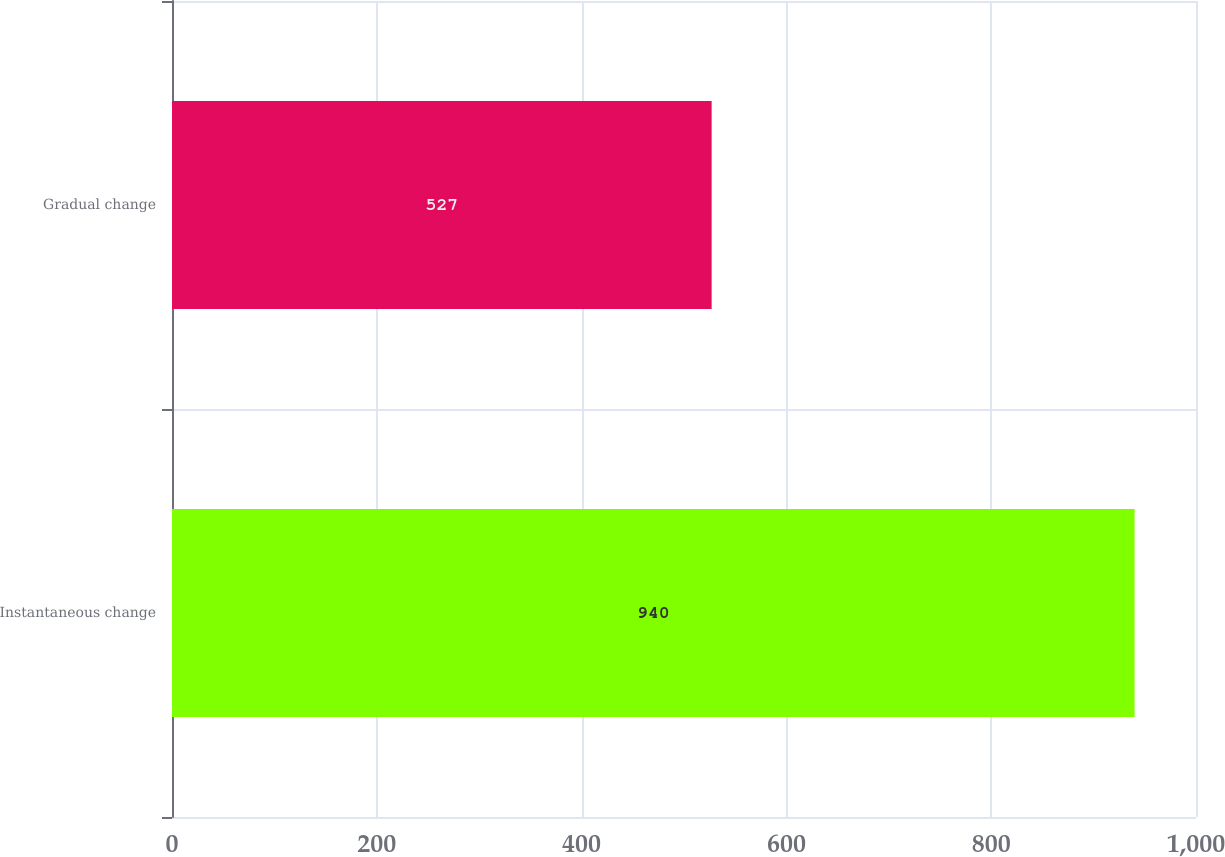Convert chart to OTSL. <chart><loc_0><loc_0><loc_500><loc_500><bar_chart><fcel>Instantaneous change<fcel>Gradual change<nl><fcel>940<fcel>527<nl></chart> 